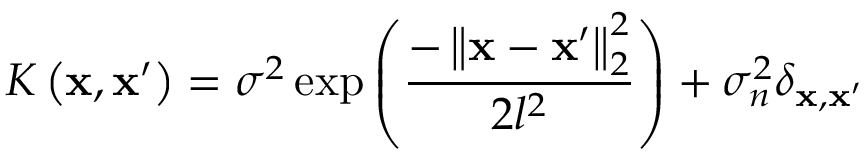Convert formula to latex. <formula><loc_0><loc_0><loc_500><loc_500>K \left ( x , x ^ { \prime } \right ) = \sigma ^ { 2 } \exp \left ( \frac { - \left \| x - x ^ { \prime } \right \| _ { 2 } ^ { 2 } } { 2 l ^ { 2 } } \right ) + \sigma _ { n } ^ { 2 } \delta _ { x , x ^ { \prime } }</formula> 